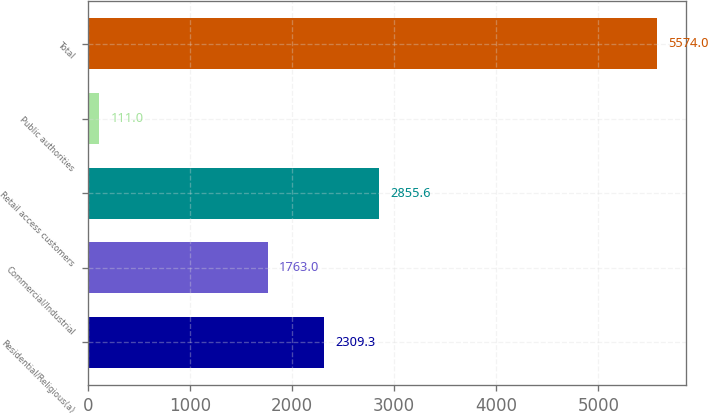Convert chart to OTSL. <chart><loc_0><loc_0><loc_500><loc_500><bar_chart><fcel>Residential/Religious(a)<fcel>Commercial/Industrial<fcel>Retail access customers<fcel>Public authorities<fcel>Total<nl><fcel>2309.3<fcel>1763<fcel>2855.6<fcel>111<fcel>5574<nl></chart> 